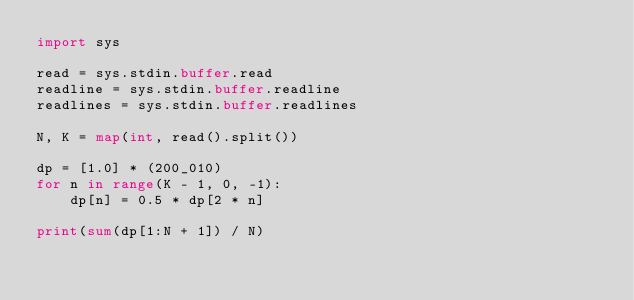Convert code to text. <code><loc_0><loc_0><loc_500><loc_500><_Python_>import sys

read = sys.stdin.buffer.read
readline = sys.stdin.buffer.readline
readlines = sys.stdin.buffer.readlines

N, K = map(int, read().split())

dp = [1.0] * (200_010)
for n in range(K - 1, 0, -1):
    dp[n] = 0.5 * dp[2 * n]

print(sum(dp[1:N + 1]) / N)</code> 